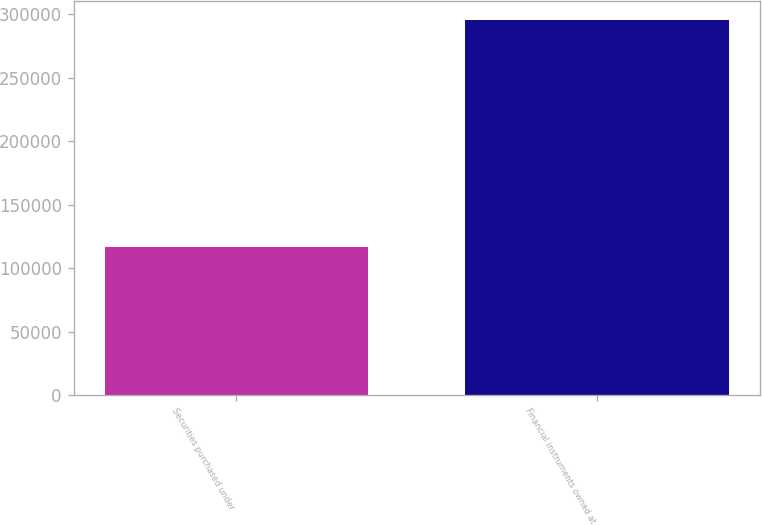Convert chart. <chart><loc_0><loc_0><loc_500><loc_500><bar_chart><fcel>Securities purchased under<fcel>Financial instruments owned at<nl><fcel>116925<fcel>295952<nl></chart> 